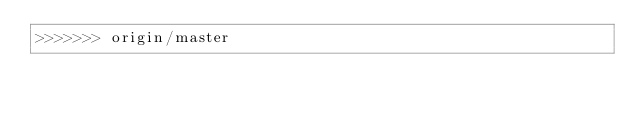Convert code to text. <code><loc_0><loc_0><loc_500><loc_500><_CSS_>>>>>>>> origin/master
</code> 